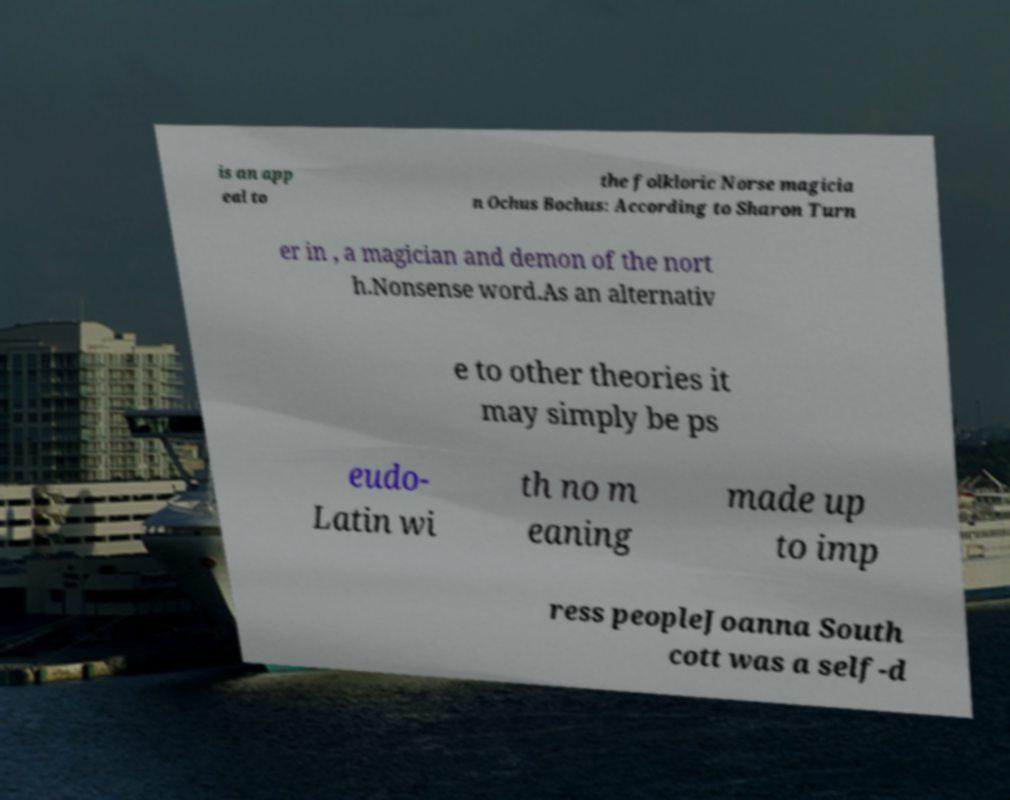Please read and relay the text visible in this image. What does it say? is an app eal to the folkloric Norse magicia n Ochus Bochus: According to Sharon Turn er in , a magician and demon of the nort h.Nonsense word.As an alternativ e to other theories it may simply be ps eudo- Latin wi th no m eaning made up to imp ress peopleJoanna South cott was a self-d 